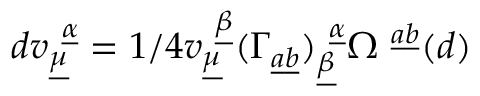<formula> <loc_0><loc_0><loc_500><loc_500>d v _ { \underline { \mu } } ^ { \underline { \alpha } } = 1 / 4 v _ { \underline { \mu } } ^ { \underline { \beta } } ( \Gamma _ { \underline { a } \underline { b } } ) _ { \underline { \beta } } ^ { \underline { \alpha } } \Omega ^ { \underline { a } \underline { b } } ( d )</formula> 